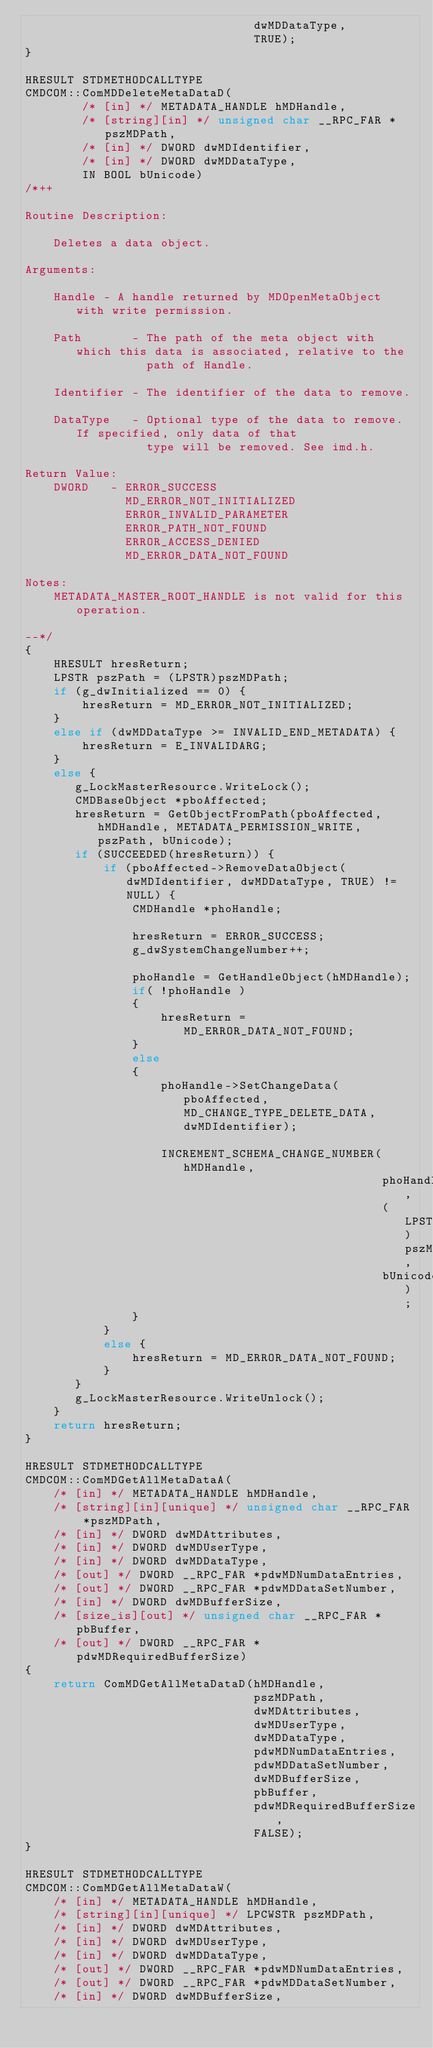Convert code to text. <code><loc_0><loc_0><loc_500><loc_500><_C++_>                                dwMDDataType,
                                TRUE);
}

HRESULT STDMETHODCALLTYPE
CMDCOM::ComMDDeleteMetaDataD(
        /* [in] */ METADATA_HANDLE hMDHandle,
        /* [string][in] */ unsigned char __RPC_FAR *pszMDPath,
        /* [in] */ DWORD dwMDIdentifier,
        /* [in] */ DWORD dwMDDataType,
        IN BOOL bUnicode)
/*++

Routine Description:

    Deletes a data object.

Arguments:

    Handle - A handle returned by MDOpenMetaObject with write permission.

    Path       - The path of the meta object with which this data is associated, relative to the
                 path of Handle.

    Identifier - The identifier of the data to remove.

    DataType   - Optional type of the data to remove. If specified, only data of that
                 type will be removed. See imd.h.

Return Value:
    DWORD   - ERROR_SUCCESS
              MD_ERROR_NOT_INITIALIZED
              ERROR_INVALID_PARAMETER
              ERROR_PATH_NOT_FOUND
              ERROR_ACCESS_DENIED
              MD_ERROR_DATA_NOT_FOUND

Notes:
    METADATA_MASTER_ROOT_HANDLE is not valid for this operation.

--*/
{
    HRESULT hresReturn;
    LPSTR pszPath = (LPSTR)pszMDPath;
    if (g_dwInitialized == 0) {
        hresReturn = MD_ERROR_NOT_INITIALIZED;
    }
    else if (dwMDDataType >= INVALID_END_METADATA) {
        hresReturn = E_INVALIDARG;
    }
    else {
       g_LockMasterResource.WriteLock();
       CMDBaseObject *pboAffected;
       hresReturn = GetObjectFromPath(pboAffected, hMDHandle, METADATA_PERMISSION_WRITE, pszPath, bUnicode);
       if (SUCCEEDED(hresReturn)) {
           if (pboAffected->RemoveDataObject(dwMDIdentifier, dwMDDataType, TRUE) != NULL) {
               CMDHandle *phoHandle;

               hresReturn = ERROR_SUCCESS;
               g_dwSystemChangeNumber++;

               phoHandle = GetHandleObject(hMDHandle);
               if( !phoHandle )
               {
                   hresReturn = MD_ERROR_DATA_NOT_FOUND;
               }
               else
               {
                   phoHandle->SetChangeData(pboAffected, MD_CHANGE_TYPE_DELETE_DATA, dwMDIdentifier);

                   INCREMENT_SCHEMA_CHANGE_NUMBER(hMDHandle,
                                                  phoHandle,
                                                  (LPSTR)pszMDPath,
                                                  bUnicode);
               }
           }
           else {
               hresReturn = MD_ERROR_DATA_NOT_FOUND;
           }
       }
       g_LockMasterResource.WriteUnlock();
    }
    return hresReturn;
}

HRESULT STDMETHODCALLTYPE
CMDCOM::ComMDGetAllMetaDataA(
    /* [in] */ METADATA_HANDLE hMDHandle,
    /* [string][in][unique] */ unsigned char __RPC_FAR *pszMDPath,
    /* [in] */ DWORD dwMDAttributes,
    /* [in] */ DWORD dwMDUserType,
    /* [in] */ DWORD dwMDDataType,
    /* [out] */ DWORD __RPC_FAR *pdwMDNumDataEntries,
    /* [out] */ DWORD __RPC_FAR *pdwMDDataSetNumber,
    /* [in] */ DWORD dwMDBufferSize,
    /* [size_is][out] */ unsigned char __RPC_FAR *pbBuffer,
    /* [out] */ DWORD __RPC_FAR *pdwMDRequiredBufferSize)
{
    return ComMDGetAllMetaDataD(hMDHandle,
                                pszMDPath,
                                dwMDAttributes,
                                dwMDUserType,
                                dwMDDataType,
                                pdwMDNumDataEntries,
                                pdwMDDataSetNumber,
                                dwMDBufferSize,
                                pbBuffer,
                                pdwMDRequiredBufferSize,
                                FALSE);
}

HRESULT STDMETHODCALLTYPE
CMDCOM::ComMDGetAllMetaDataW(
    /* [in] */ METADATA_HANDLE hMDHandle,
    /* [string][in][unique] */ LPCWSTR pszMDPath,
    /* [in] */ DWORD dwMDAttributes,
    /* [in] */ DWORD dwMDUserType,
    /* [in] */ DWORD dwMDDataType,
    /* [out] */ DWORD __RPC_FAR *pdwMDNumDataEntries,
    /* [out] */ DWORD __RPC_FAR *pdwMDDataSetNumber,
    /* [in] */ DWORD dwMDBufferSize,</code> 